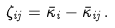Convert formula to latex. <formula><loc_0><loc_0><loc_500><loc_500>\zeta _ { i j } = \bar { \kappa } _ { i } - \bar { \kappa } _ { i j } \, .</formula> 